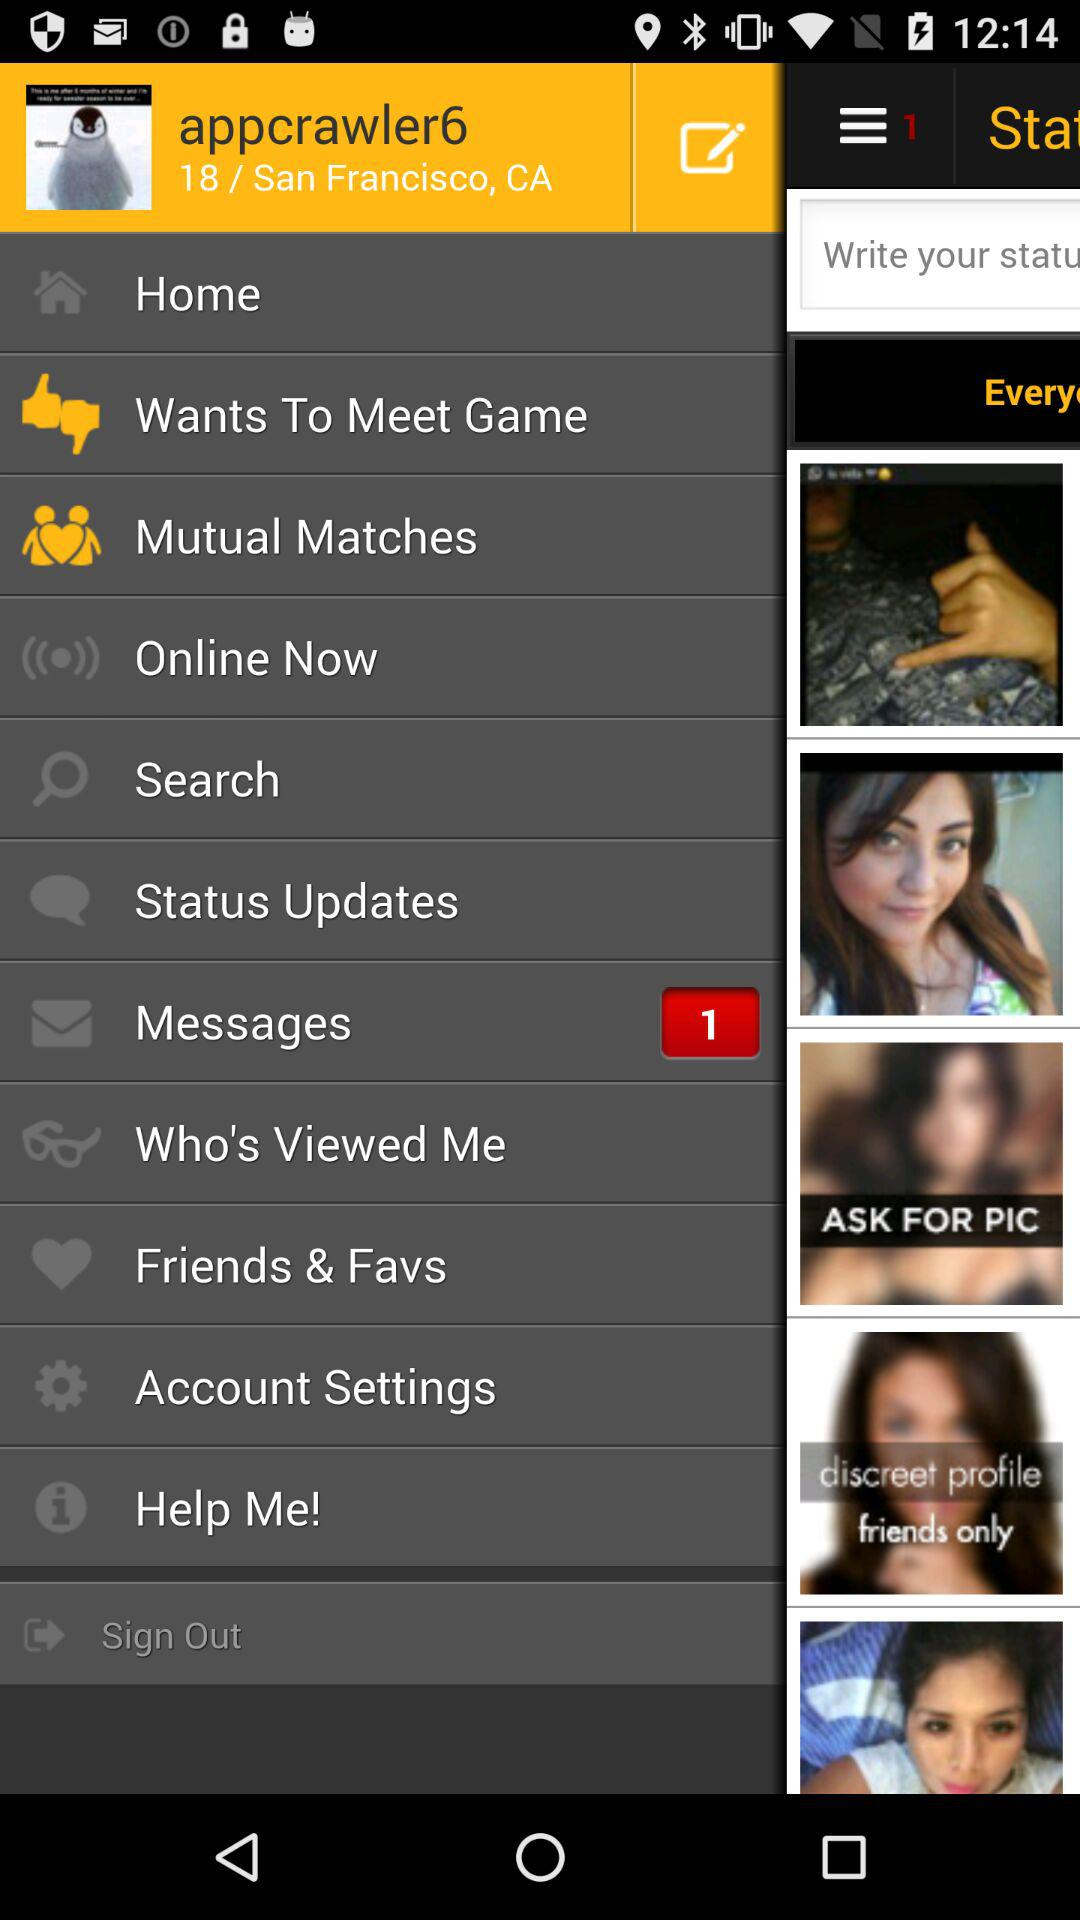What is the name of the user? The name of the user is appcrawler6. 